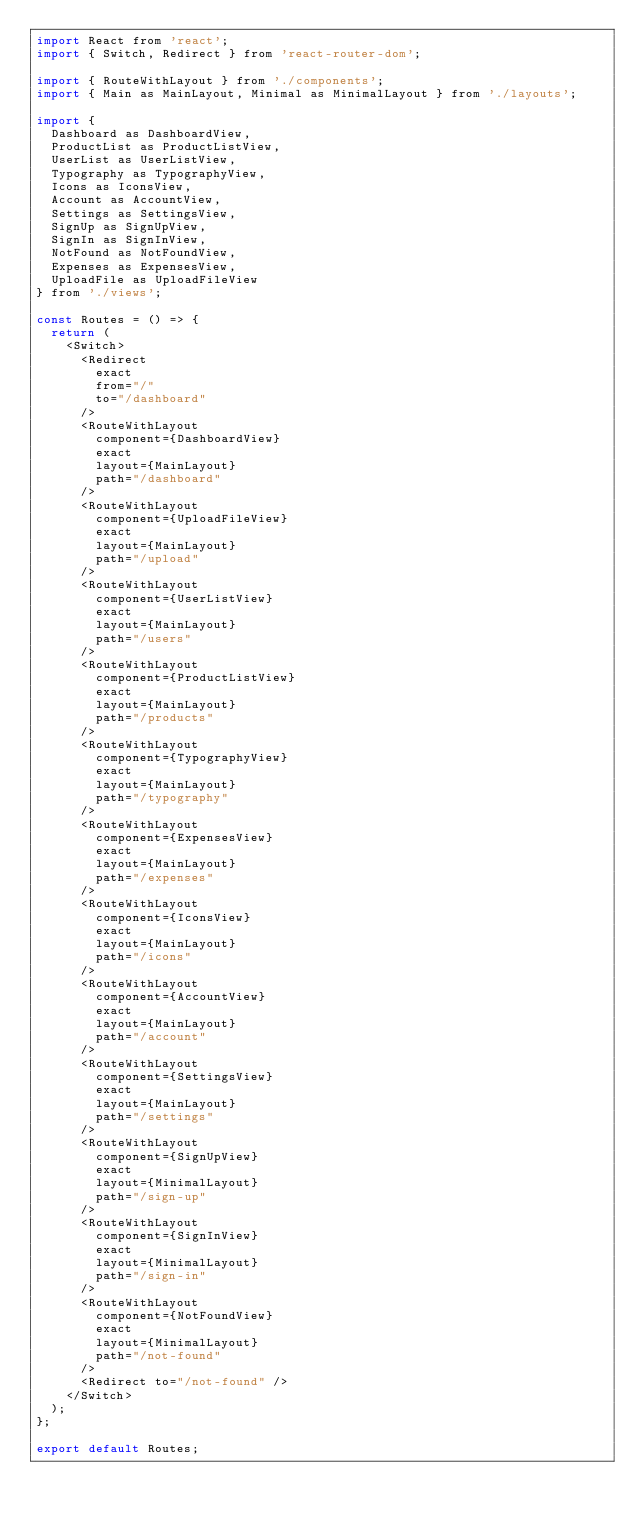<code> <loc_0><loc_0><loc_500><loc_500><_JavaScript_>import React from 'react';
import { Switch, Redirect } from 'react-router-dom';

import { RouteWithLayout } from './components';
import { Main as MainLayout, Minimal as MinimalLayout } from './layouts';

import {
  Dashboard as DashboardView,
  ProductList as ProductListView,
  UserList as UserListView,
  Typography as TypographyView,
  Icons as IconsView,
  Account as AccountView,
  Settings as SettingsView,
  SignUp as SignUpView,
  SignIn as SignInView,
  NotFound as NotFoundView,
  Expenses as ExpensesView,
  UploadFile as UploadFileView
} from './views';

const Routes = () => {
  return (
    <Switch>
      <Redirect
        exact
        from="/"
        to="/dashboard"
      />
      <RouteWithLayout
        component={DashboardView}
        exact
        layout={MainLayout}
        path="/dashboard"
      />
      <RouteWithLayout
        component={UploadFileView}
        exact
        layout={MainLayout}
        path="/upload"
      />
      <RouteWithLayout
        component={UserListView}
        exact
        layout={MainLayout}
        path="/users"
      />
      <RouteWithLayout
        component={ProductListView}
        exact
        layout={MainLayout}
        path="/products"
      />
      <RouteWithLayout
        component={TypographyView}
        exact
        layout={MainLayout}
        path="/typography"
      />
      <RouteWithLayout
        component={ExpensesView}
        exact
        layout={MainLayout}
        path="/expenses"
      />
      <RouteWithLayout
        component={IconsView}
        exact
        layout={MainLayout}
        path="/icons"
      />
      <RouteWithLayout
        component={AccountView}
        exact
        layout={MainLayout}
        path="/account"
      />
      <RouteWithLayout
        component={SettingsView}
        exact
        layout={MainLayout}
        path="/settings"
      />
      <RouteWithLayout
        component={SignUpView}
        exact
        layout={MinimalLayout}
        path="/sign-up"
      />
      <RouteWithLayout
        component={SignInView}
        exact
        layout={MinimalLayout}
        path="/sign-in"
      />
      <RouteWithLayout
        component={NotFoundView}
        exact
        layout={MinimalLayout}
        path="/not-found"
      />
      <Redirect to="/not-found" />
    </Switch>
  );
};

export default Routes;
</code> 